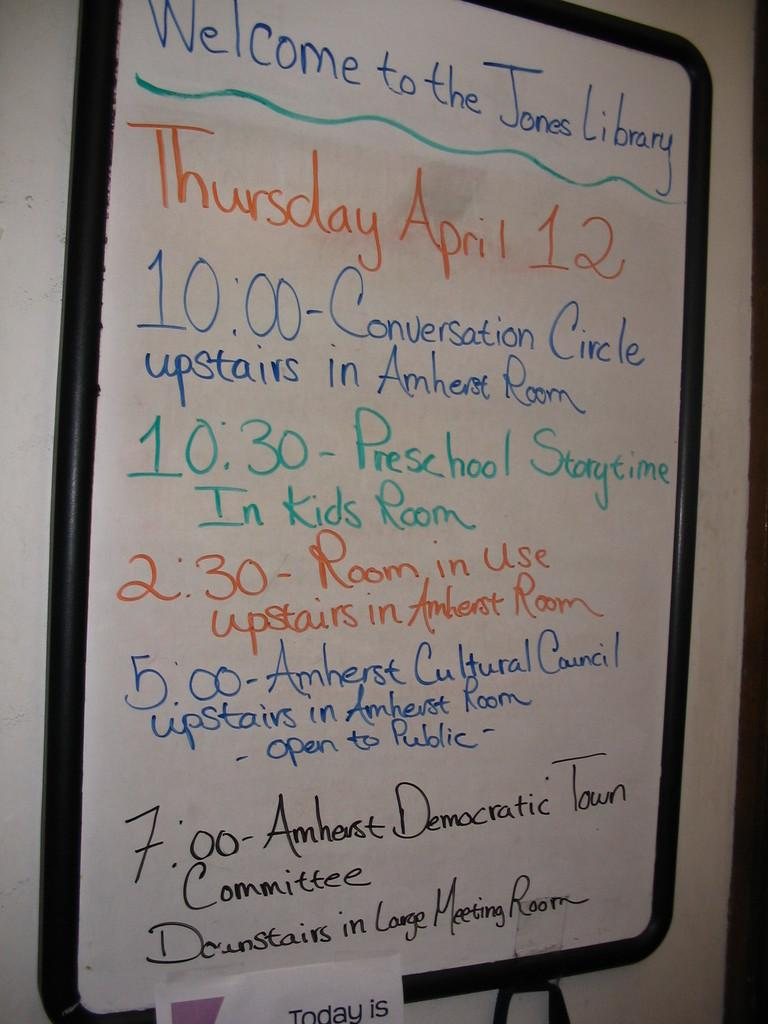<image>
Share a concise interpretation of the image provided. A white board welcomes visitors to the Jones library. 